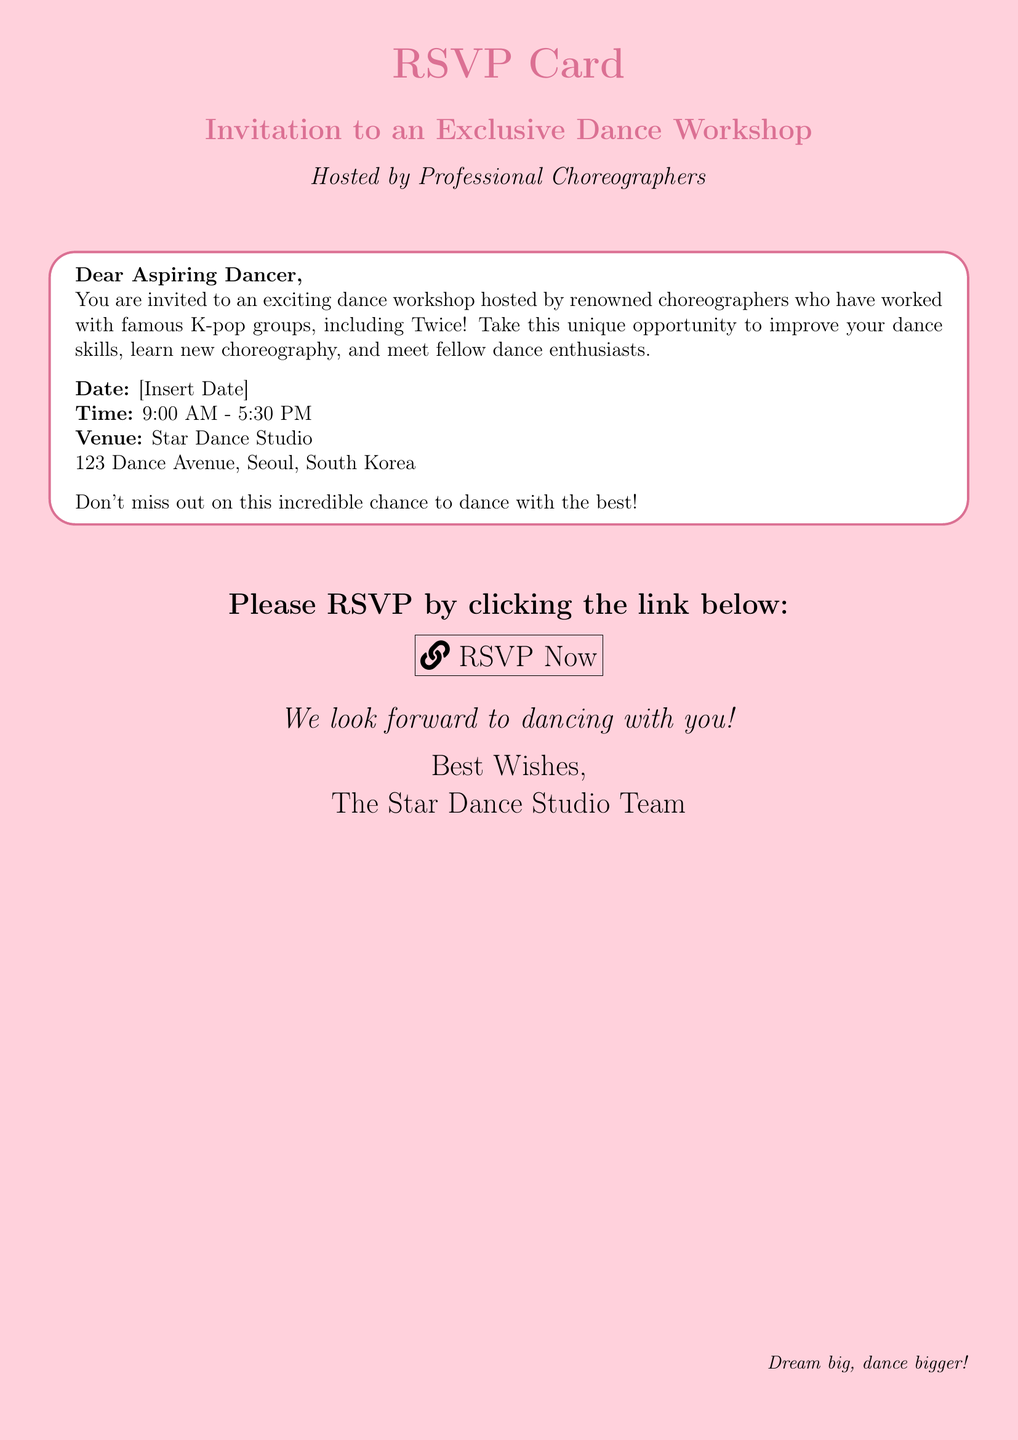What is the date of the workshop? The date is specified as [Insert Date] in the document, indicating that the actual date will be provided.
Answer: [Insert Date] What time does the workshop start? The starting time of the workshop is mentioned as 9:00 AM in the document.
Answer: 9:00 AM What is the venue for the dance workshop? The workshop venue is clearly stated as Star Dance Studio, which is the location for the event.
Answer: Star Dance Studio Who is hosting the dance workshop? The document indicates that the dance workshop is hosted by professional choreographers.
Answer: Professional Choreographers What is one benefit mentioned for attending the workshop? The document highlights meeting fellow dance enthusiasts as a benefit of attending the workshop.
Answer: Meet fellow dance enthusiasts What should you do to confirm your attendance? The document suggests clicking a link to RSVP for the workshop.
Answer: Click the link to RSVP What type of event is this document promoting? The document is promoting an exclusive dance workshop specifically aimed at dancers.
Answer: Dance workshop Which popular K-pop group is mentioned in relation to the choreographers? The document references Twice as a famous K-pop group connected to the choreographers.
Answer: Twice 